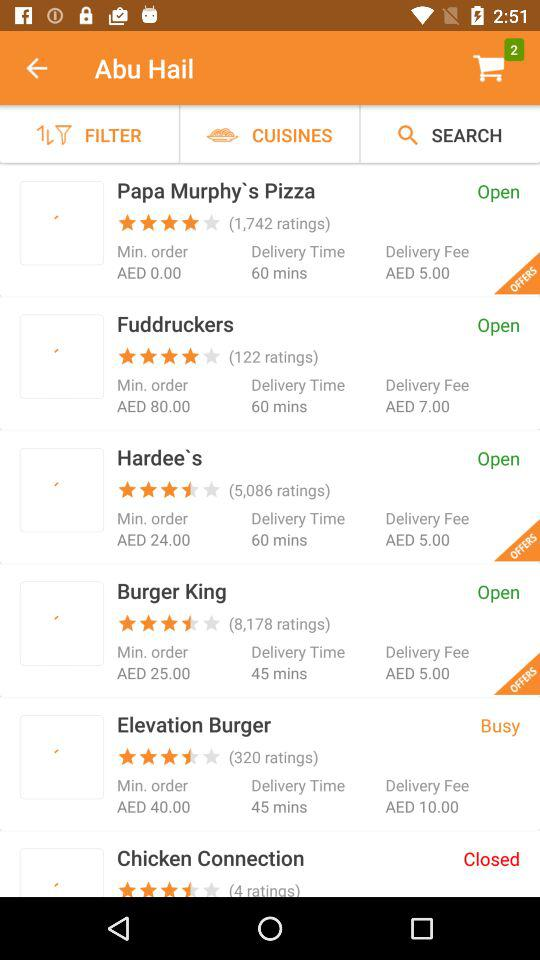What is the minimum order value to order from "Burger King"? The minimum order value is AED 25.00. 